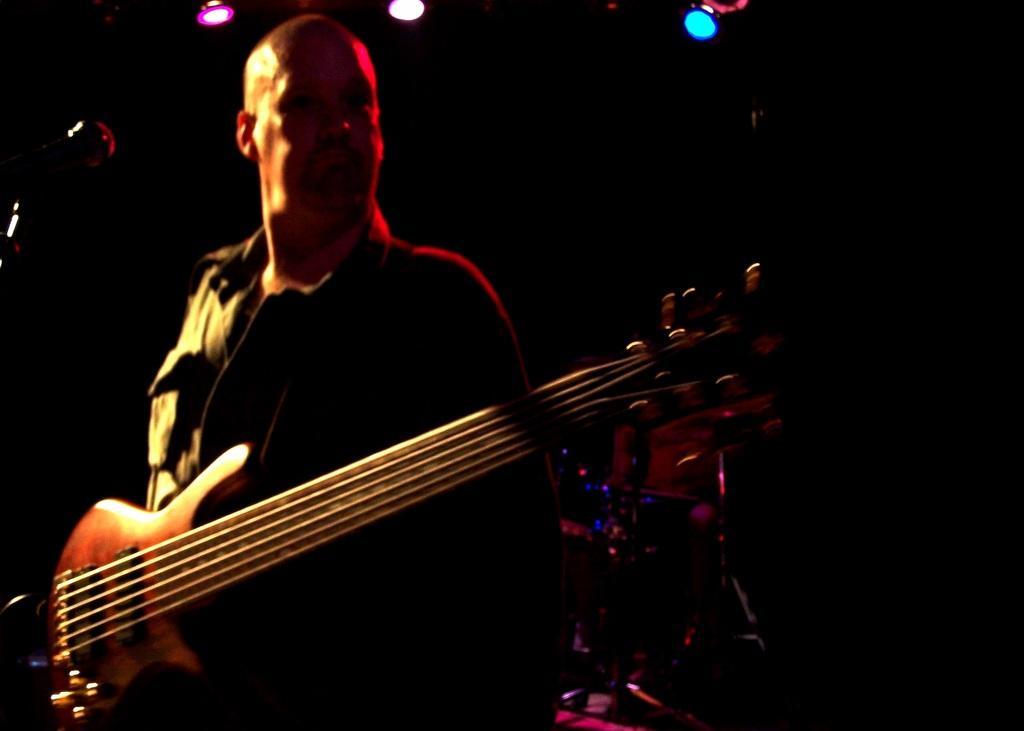How would you summarize this image in a sentence or two? This picture seems to be of inside. In the foreground we can see a man standing wearing guitar. In the background we can see the focusing lights and there is a microphone seems to be attached to the stand. 